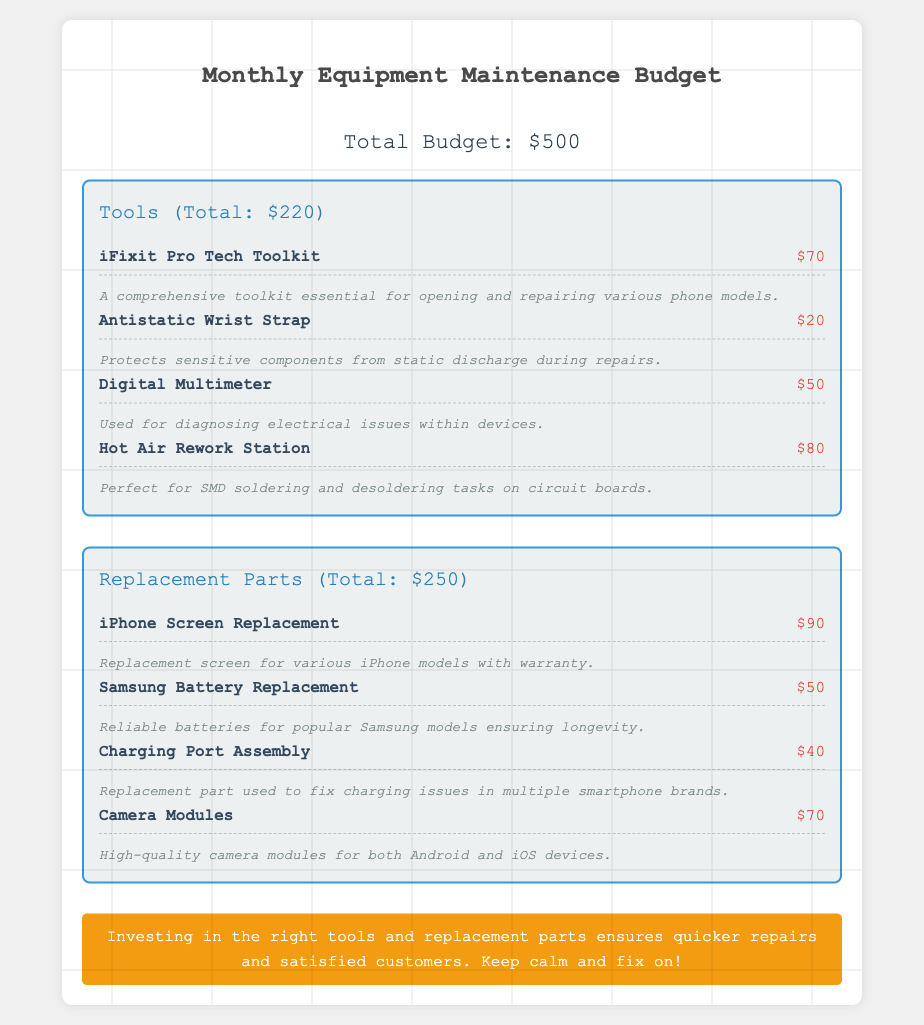What is the total budget? The total budget is displayed at the top of the document as $500.
Answer: $500 How much does the iFixit Pro Tech Toolkit cost? The toolkit is listed in the Tools section with a cost of $70.
Answer: $70 What is the cost of the Camera Modules? The Camera Modules are noted in the Replacement Parts section with a cost of $70.
Answer: $70 What is the total cost of Tools? The Tools section shows a total of $220 for all tools listed.
Answer: $220 Which tool protects sensitive components from static discharge? The Antistatic Wrist Strap is mentioned as providing protection from static discharge.
Answer: Antistatic Wrist Strap How much does the Samsung Battery Replacement cost? The Samsung Battery Replacement price is listed in the Replacement Parts section as $50.
Answer: $50 What is the combined cost of the iPhone Screen Replacement and the Charging Port Assembly? The iPhone Screen Replacement is $90 and the Charging Port Assembly is $40, adding up to $130.
Answer: $130 Which section has the highest total cost? A comparison of the totals shows that the Replacement Parts section at $250 has the highest cost.
Answer: Replacement Parts What investment is suggested for quicker repairs? The note advises that investing in the right tools and replacement parts is essential for quicker repairs.
Answer: Tools and replacement parts 